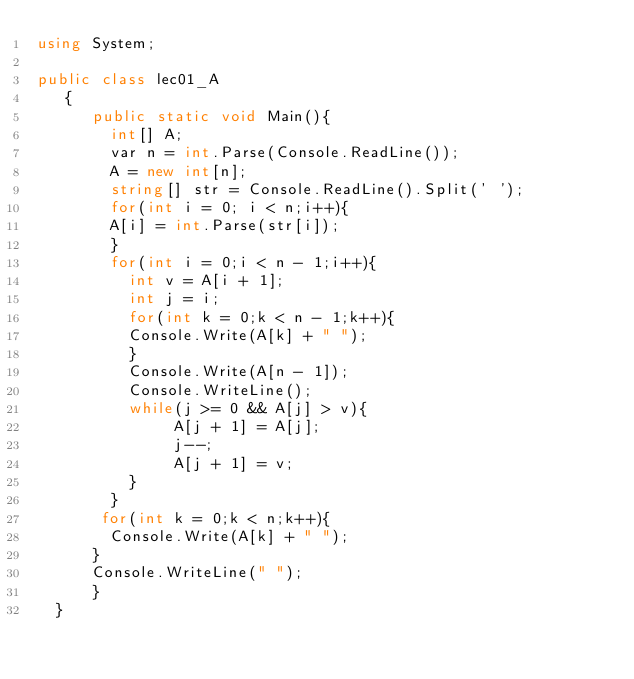<code> <loc_0><loc_0><loc_500><loc_500><_C#_>using System;

public class lec01_A
   {
      public static void Main(){
        int[] A;
        var n = int.Parse(Console.ReadLine());
        A = new int[n];
        string[] str = Console.ReadLine().Split(' ');
        for(int i = 0; i < n;i++){
        A[i] = int.Parse(str[i]);
        }
        for(int i = 0;i < n - 1;i++){
          int v = A[i + 1];
          int j = i;
          for(int k = 0;k < n - 1;k++){
          Console.Write(A[k] + " ");
          }
          Console.Write(A[n - 1]);
          Console.WriteLine();
          while(j >= 0 && A[j] > v){
               A[j + 1] = A[j];
               j--;
               A[j + 1] = v;
          }
        }
       for(int k = 0;k < n;k++){
        Console.Write(A[k] + " ");
      }
      Console.WriteLine(" ");
      }
  }

</code> 